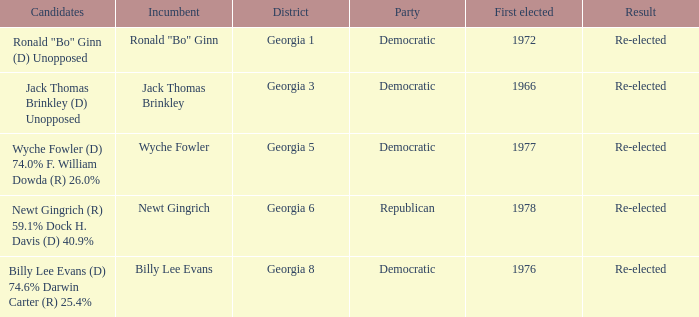How many parties were for candidates newt gingrich (r) 59.1% dock h. davis (d) 40.9%? 1.0. 